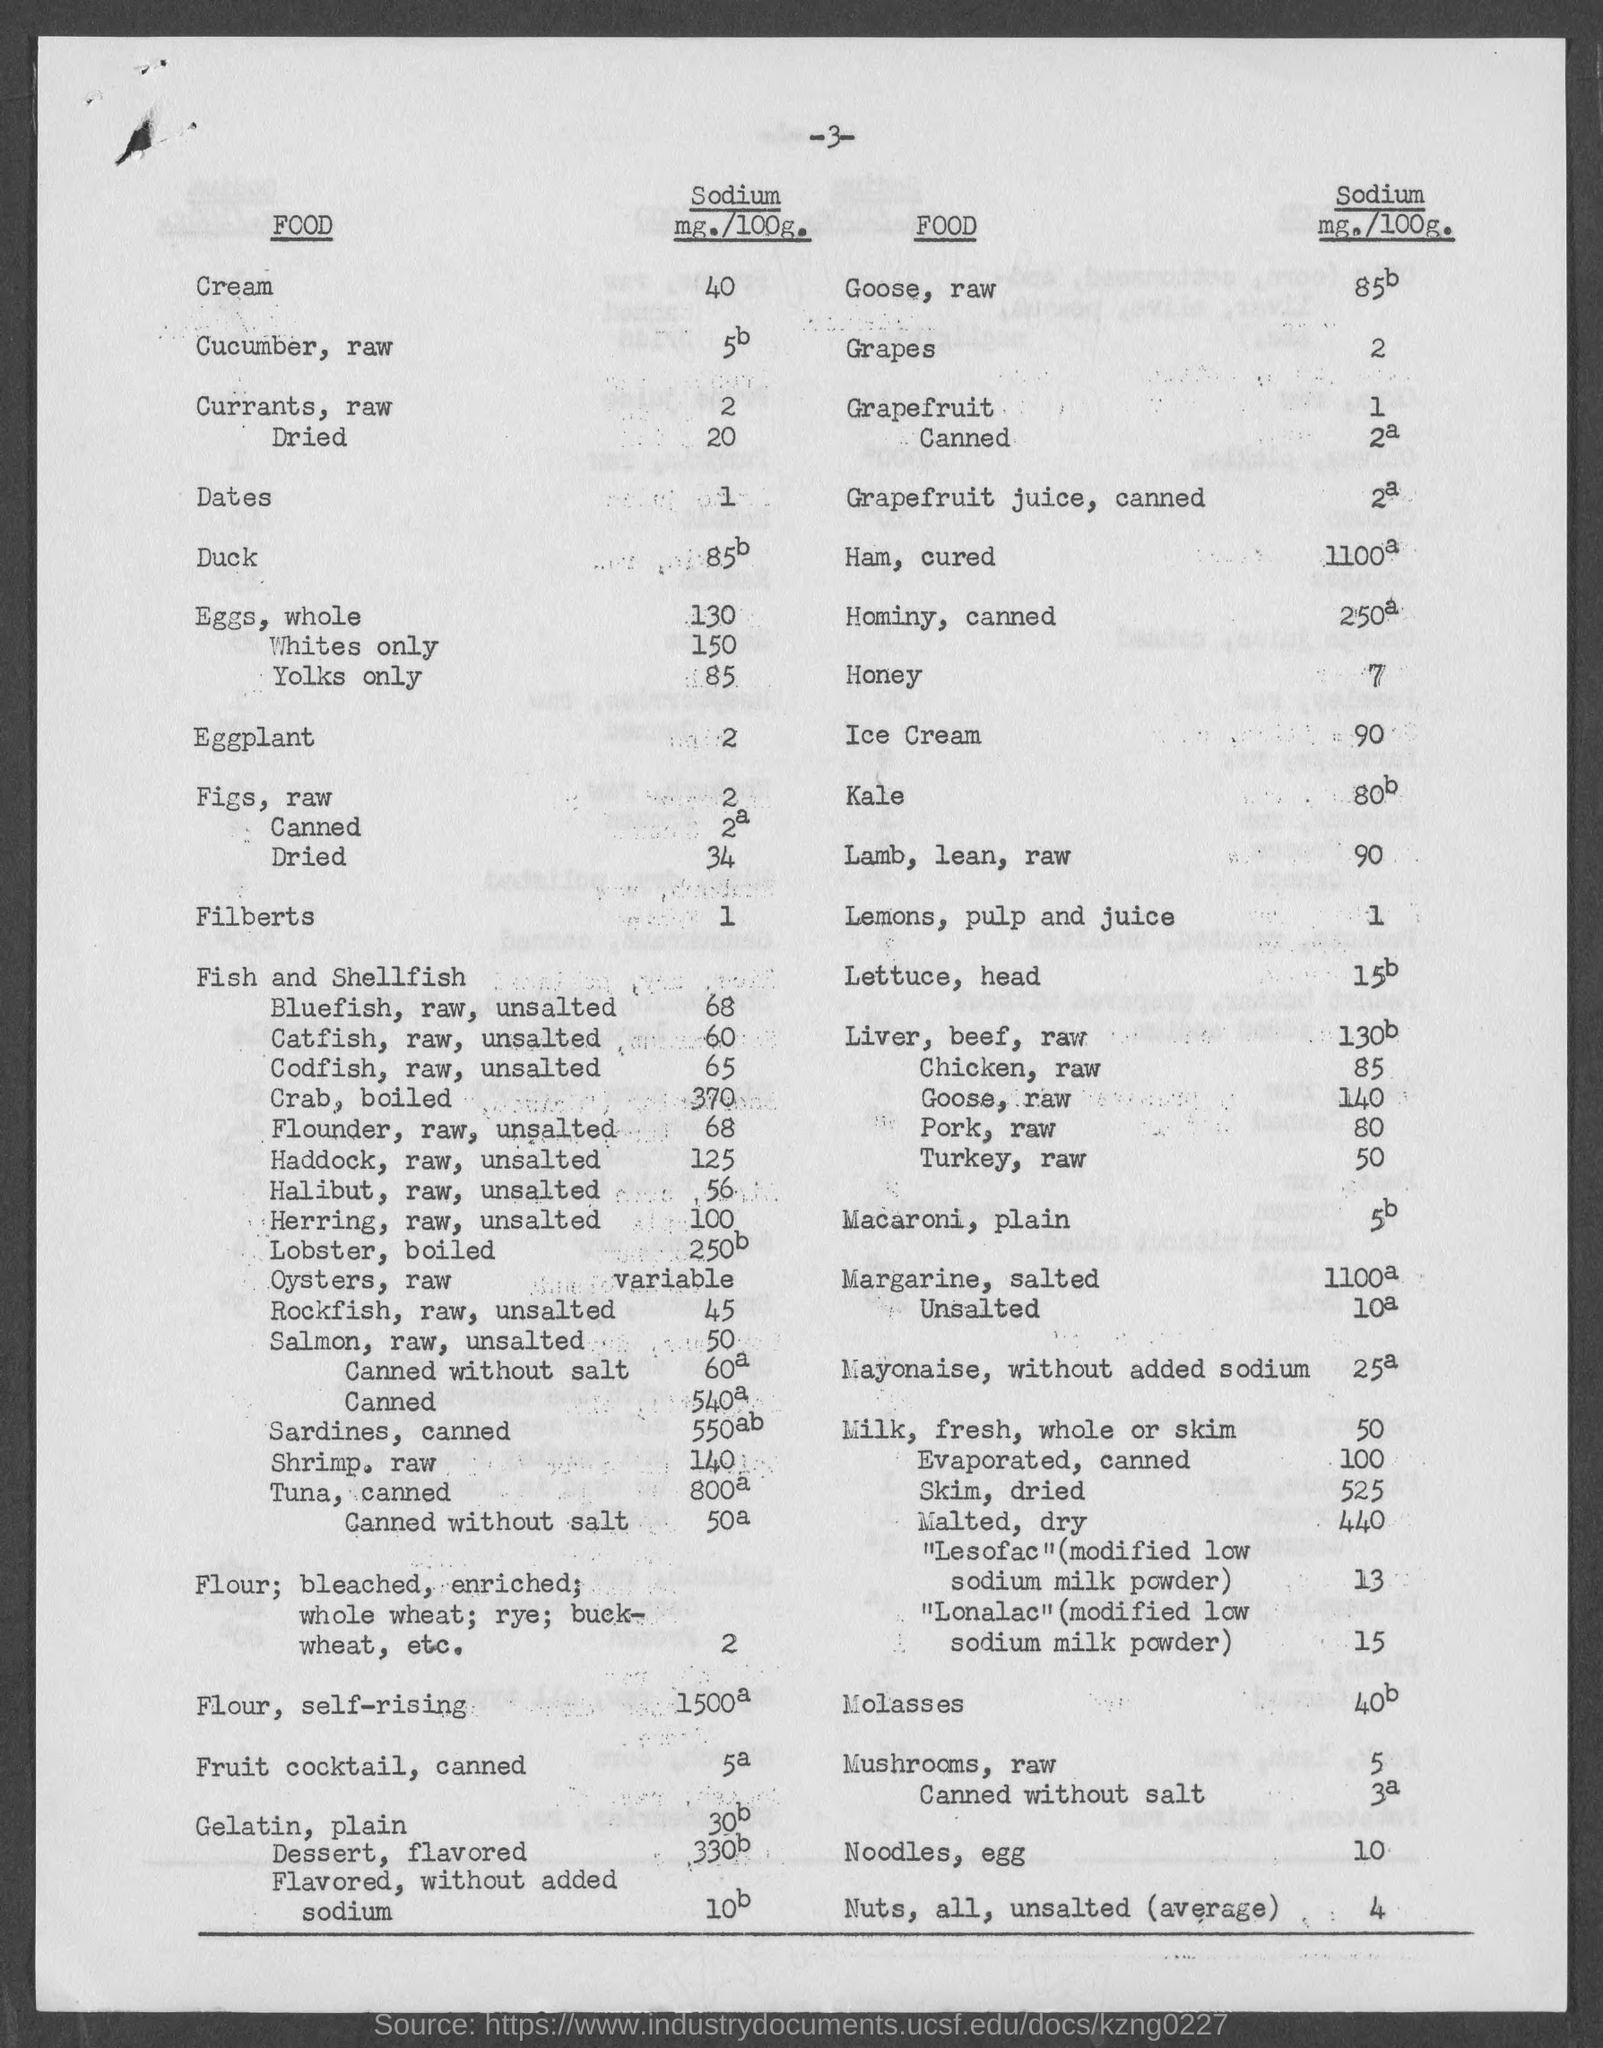What is the page no mentioned in this document?
Your answer should be compact. -3-. What is the amount of sodium (mg./100g.) present in dates?
Make the answer very short. 1. What is the amount of sodium (mg./100g.) present in Eggplant?
Provide a succinct answer. 2. What is the amount of sodium (mg./100g.) present in Honey?
Keep it short and to the point. 7. What is the amount of sodium (mg./100g.) present in Grapes?
Provide a short and direct response. 2. 